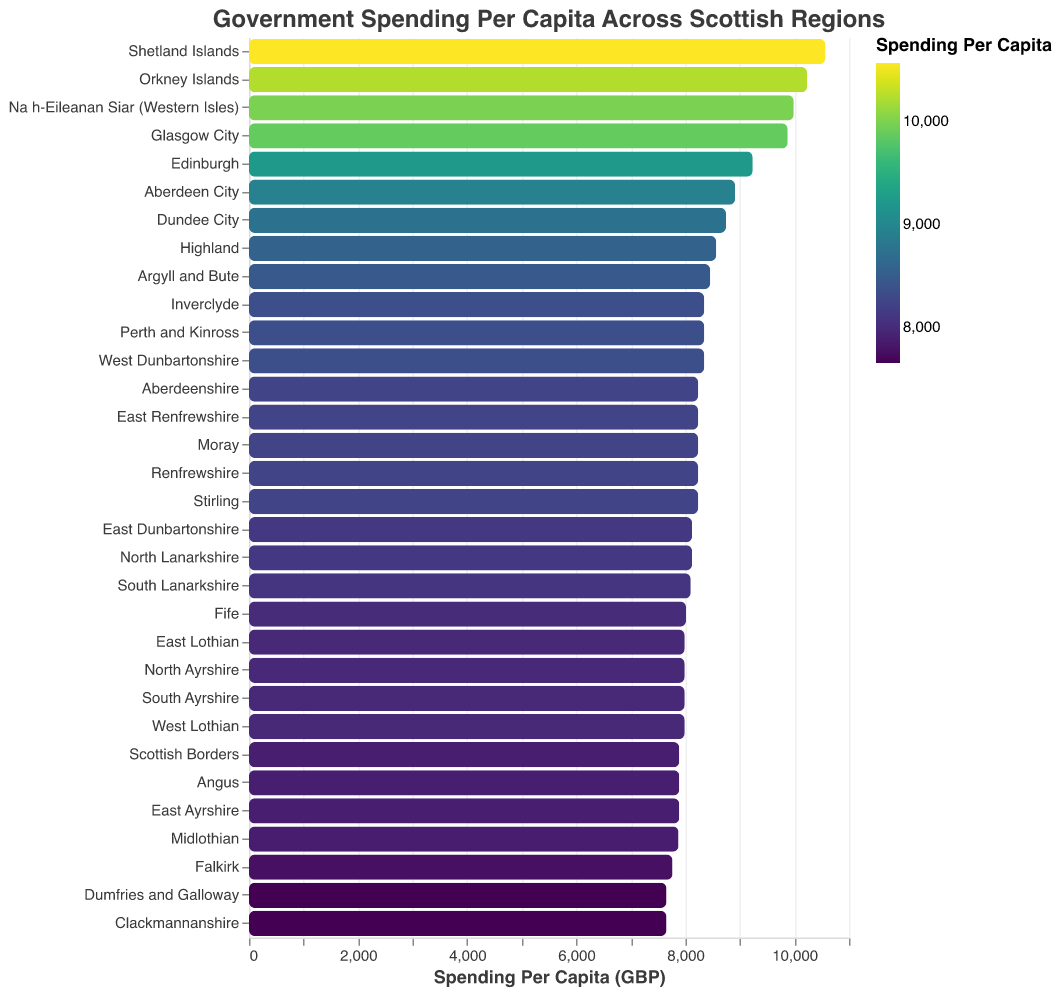What is the title of the figure? The title is typically displayed at the top of the figure. In this case, it states "Government Spending Per Capita Across Scottish Regions."
Answer: Government Spending Per Capita Across Scottish Regions Which region has the highest government spending per capita? By examining the bars in the figure, the highest spending is color-coded with the most intense shade. The Shetland Islands show the highest bar length, indicating it has the highest spending.
Answer: Shetland Islands What is the government spending per capita for Dumfries and Galloway? Find the bar corresponding to Dumfries and Galloway; its position along the x-axis indicates its spending. According to the provided data, it aligns with 7654 GBP.
Answer: 7654 GBP How does the spending in Edinburgh compare to that in Aberdeen City? Locate both bars for Edinburgh and Aberdeen City. Edinburgh's bar is slightly longer than Aberdeen City, indicating a higher spending. The exact spending is 9234 GBP for Edinburgh and 8912 GBP for Aberdeen City.
Answer: Edinburgh: 9234 GBP, Aberdeen City: 8912 GBP What is the sum of the government spending per capita for Orkney Islands and Na h-Eileanan Siar (Western Isles)? Sum the spending values of both regions - Orkney Islands (10234) and Na h-Eileanan Siar (9987). The calculation is 10234 + 9987.
Answer: 20221 GBP Which regions have the closest government spending per capita to the Scottish Borders? The Scottish Borders have a spending value of 7890 GBP. Regions with the same spending per capita of 7890 GBP are Angus, East Ayrshire, and Scottish Borders itself.
Answer: Angus, East Ayrshire What is the median value of government spending per capita across all regions? List the spending values in ascending order and find the middle value. If the total number of regions is even, the median is the average of the two middle values. Here, there are 32 regions, so the median is the average of the 16th and 17th values.
Answer: 8123 GBP Which region has the lowest government spending per capita and what is its value? Identify the shortest bar in the figure, which indicates the lowest spending. Dumfries and Galloway have the lowest spending value of 7654 GBP.
Answer: Dumfries and Galloway, 7654 GBP What is the difference in government spending per capita between Glasgow City and Edinburgh? Subtract Edinburgh's spending from Glasgow City's spending: 9876 - 9234. The difference is 642 GBP.
Answer: 642 GBP How many regions have a spending per capita greater than 8000 GBP? Count the number of bars that extend beyond the 8000 GBP mark on the x-axis. From the figure, 19 regions surpass this threshold.
Answer: 19 regions 